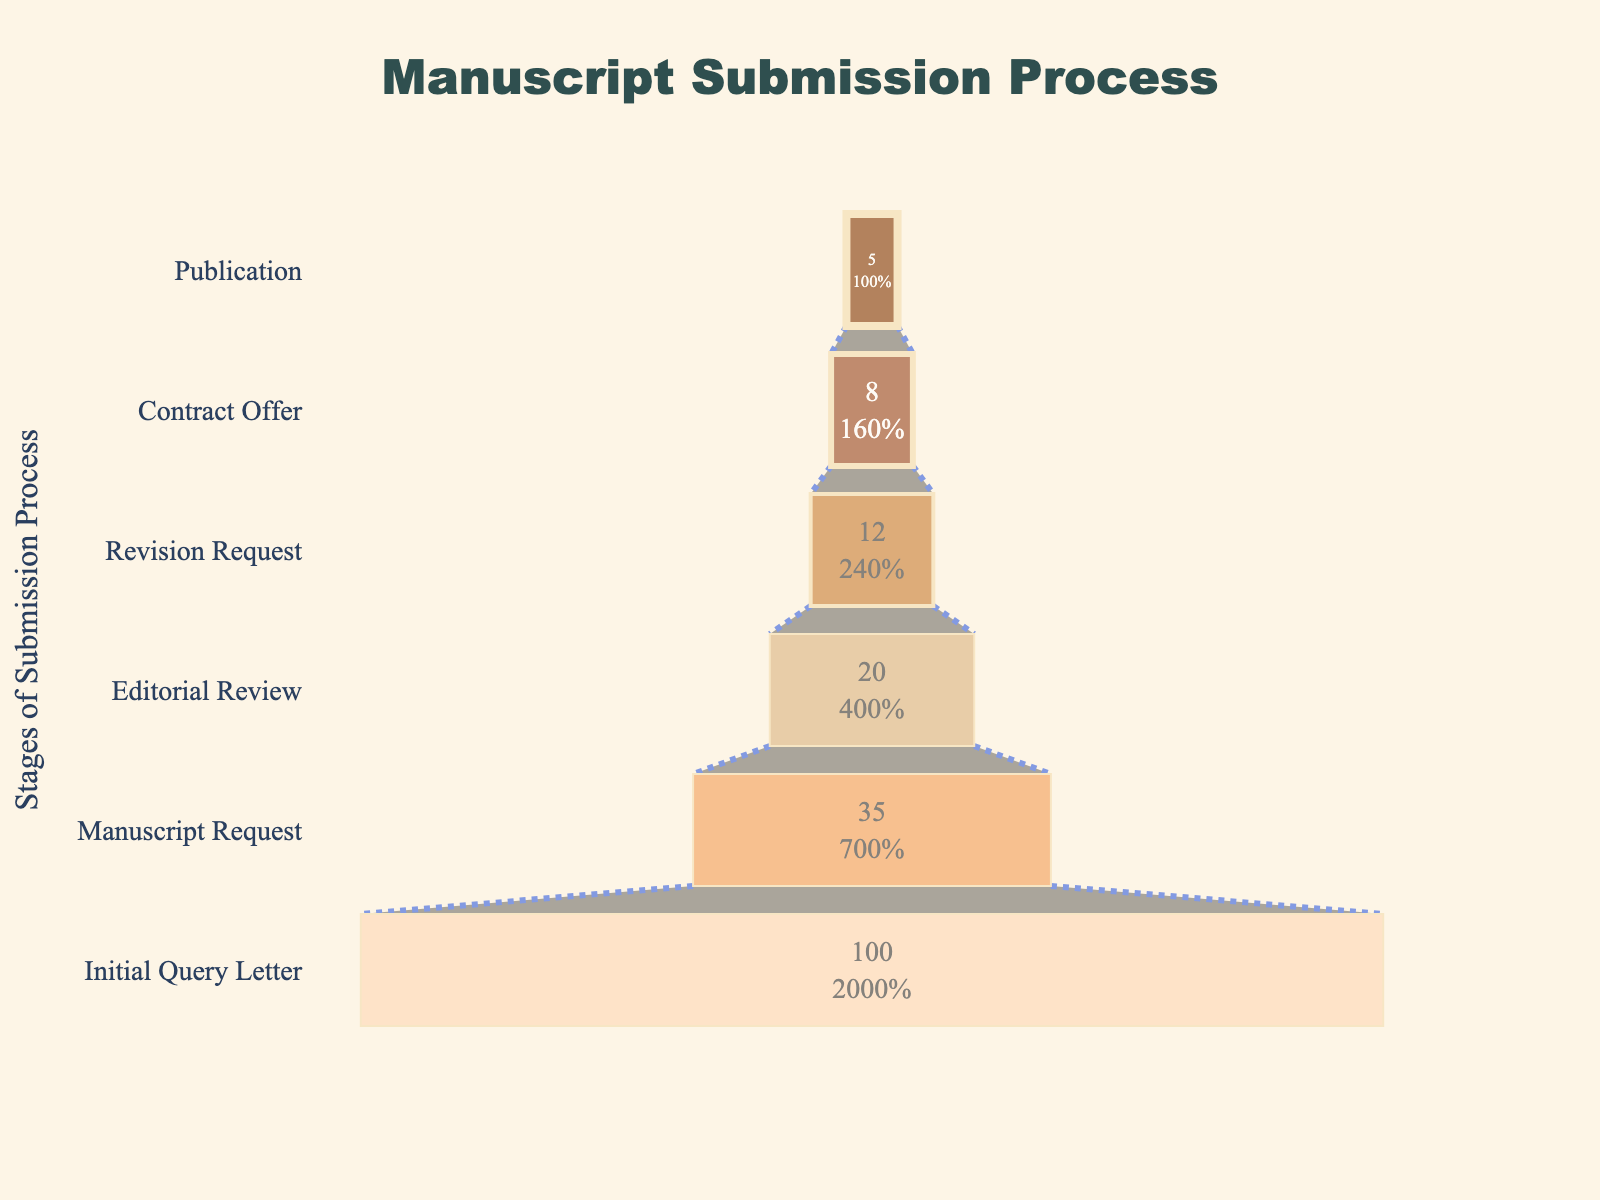What is the title of the funnel chart? The chart's title is located at the top of the figure, in a large font size, and reads as the header of the visual representation.
Answer: "Manuscript Submission Process" Which stage has the highest success rate? The stage with the highest success rate is indicated by the segment at the widest part of the funnel. The percentage shown is 100%.
Answer: Initial Query Letter At which stage does the success rate drop the most compared to the previous stage? To find the stage with the largest drop in success rate, calculate the difference in percentages between consecutive stages and identify the greatest difference. The drop from Initial Query Letter (100%) to Manuscript Request (35%) is 65%.
Answer: Initial Query Letter to Manuscript Request What is the success rate at the Contract Offer stage? Locate the Contract Offer stage in the funnel chart and read the accompanying percentage value displayed on it.
Answer: 8% How many stages are represented in the funnel chart? Count the number of distinct segments or stages labeled in the funnel chart.
Answer: 6 What percentage of manuscripts make it to the Publication stage? Identify the section labeled Publication in the funnel chart and read the success rate percentage displayed on it.
Answer: 5% How does the success rate at the Revision Request stage compare to the success rate at the Editorial Review stage? Look at both Revision Request and Editorial Review stages and compare their percentages: Revision Request is 12%, Editorial Review is 20%.
Answer: The success rate at the Revision Request stage is less than the Editorial Review stage What is the total percentage drop from Initial Query Letter to Contract Offer? Subtract the Contract Offer percentage from the Initial Query Letter percentage: 100% - 8% = 92%.
Answer: 92% What stage follows the Manuscript Request stage in terms of decreasing success rate? Identify the stages in descending order of success rate and note the order following Manuscript Request.
Answer: Editorial Review Which two stages have the smallest drop in success rate between them? Calculate the percentage difference between each pair of consecutive stages and identify the smallest change: Editorial Review (20%) to Revision Request (12%). Difference is 8%.
Answer: Editorial Review to Revision Request 